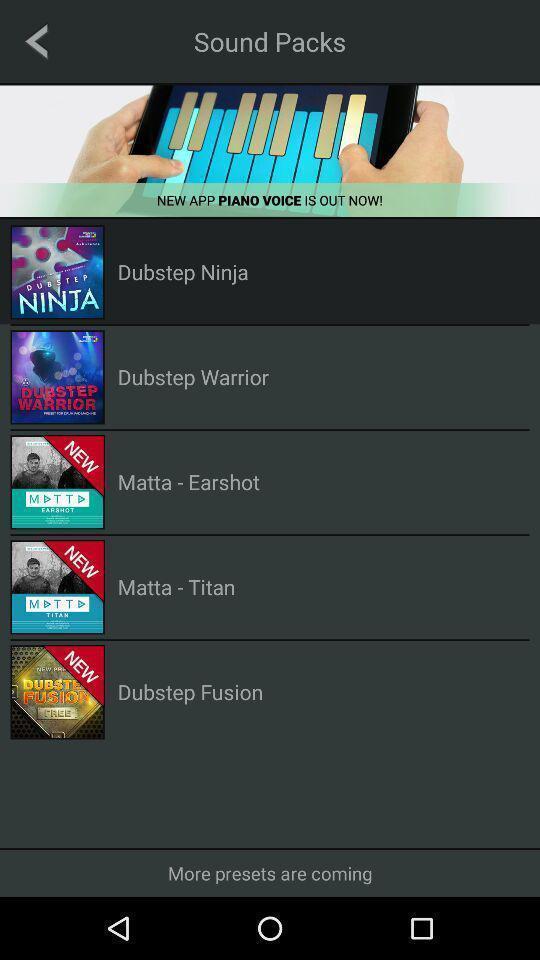Tell me what you see in this picture. Screen displaying list of sounds. 